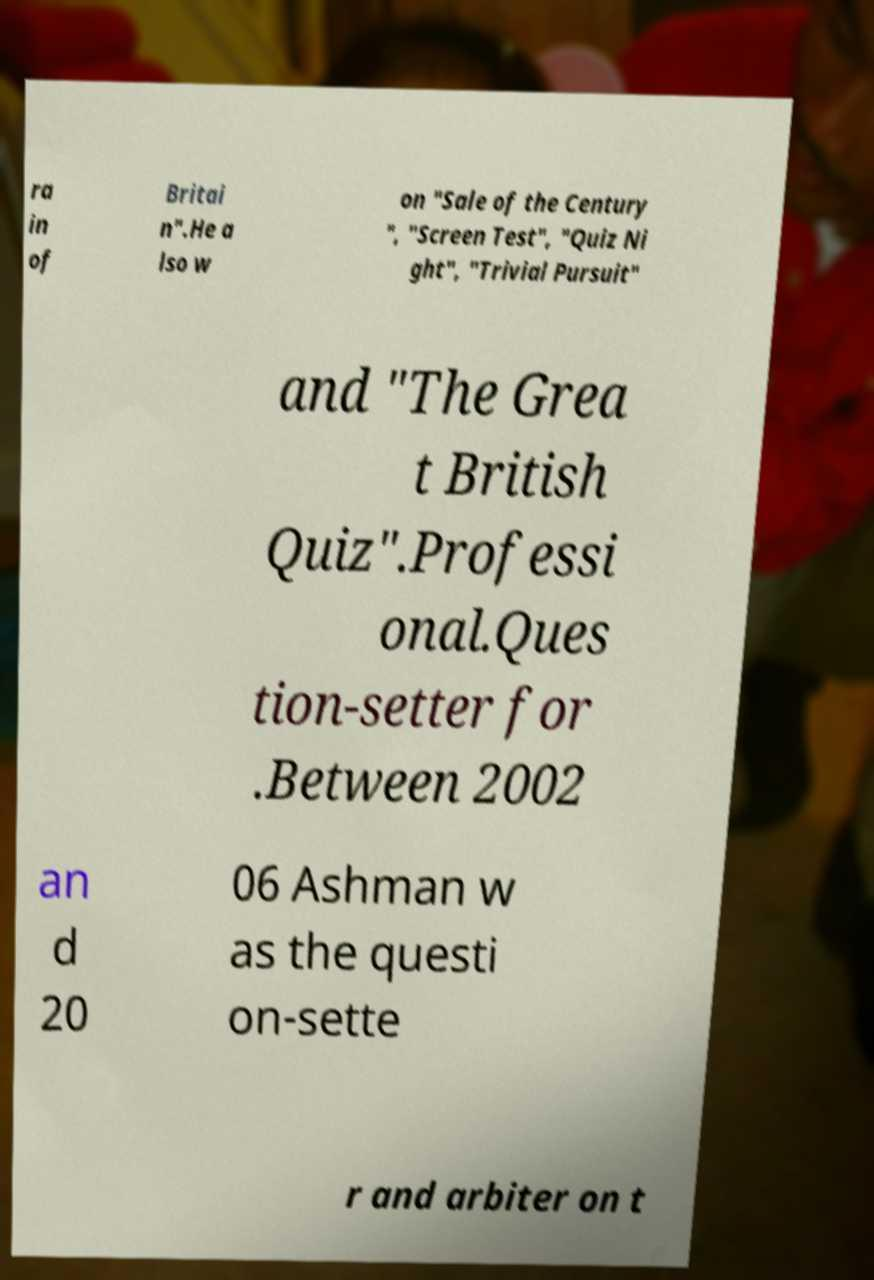Please identify and transcribe the text found in this image. ra in of Britai n".He a lso w on "Sale of the Century ", "Screen Test", "Quiz Ni ght", "Trivial Pursuit" and "The Grea t British Quiz".Professi onal.Ques tion-setter for .Between 2002 an d 20 06 Ashman w as the questi on-sette r and arbiter on t 